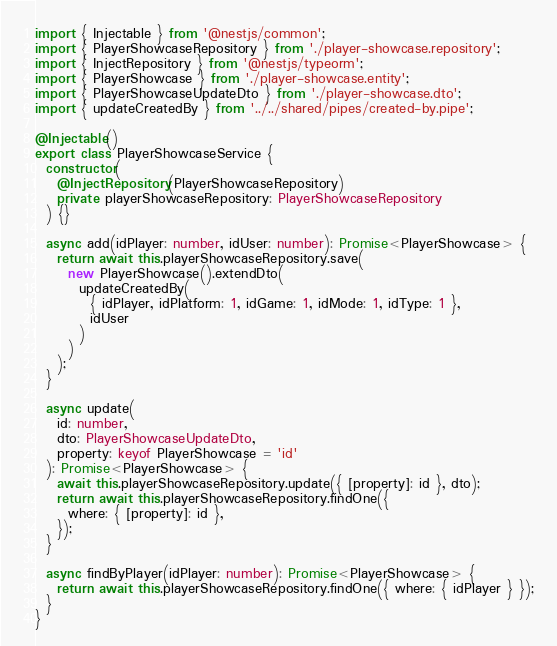Convert code to text. <code><loc_0><loc_0><loc_500><loc_500><_TypeScript_>import { Injectable } from '@nestjs/common';
import { PlayerShowcaseRepository } from './player-showcase.repository';
import { InjectRepository } from '@nestjs/typeorm';
import { PlayerShowcase } from './player-showcase.entity';
import { PlayerShowcaseUpdateDto } from './player-showcase.dto';
import { updateCreatedBy } from '../../shared/pipes/created-by.pipe';

@Injectable()
export class PlayerShowcaseService {
  constructor(
    @InjectRepository(PlayerShowcaseRepository)
    private playerShowcaseRepository: PlayerShowcaseRepository
  ) {}

  async add(idPlayer: number, idUser: number): Promise<PlayerShowcase> {
    return await this.playerShowcaseRepository.save(
      new PlayerShowcase().extendDto(
        updateCreatedBy(
          { idPlayer, idPlatform: 1, idGame: 1, idMode: 1, idType: 1 },
          idUser
        )
      )
    );
  }

  async update(
    id: number,
    dto: PlayerShowcaseUpdateDto,
    property: keyof PlayerShowcase = 'id'
  ): Promise<PlayerShowcase> {
    await this.playerShowcaseRepository.update({ [property]: id }, dto);
    return await this.playerShowcaseRepository.findOne({
      where: { [property]: id },
    });
  }

  async findByPlayer(idPlayer: number): Promise<PlayerShowcase> {
    return await this.playerShowcaseRepository.findOne({ where: { idPlayer } });
  }
}
</code> 